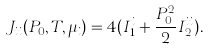Convert formula to latex. <formula><loc_0><loc_0><loc_500><loc_500>J _ { i i } ( P _ { 0 } , T , \mu _ { i } ) = 4 ( I _ { 1 } ^ { i } + \frac { P _ { 0 } ^ { 2 } } { 2 } I _ { 2 } ^ { i i } ) .</formula> 